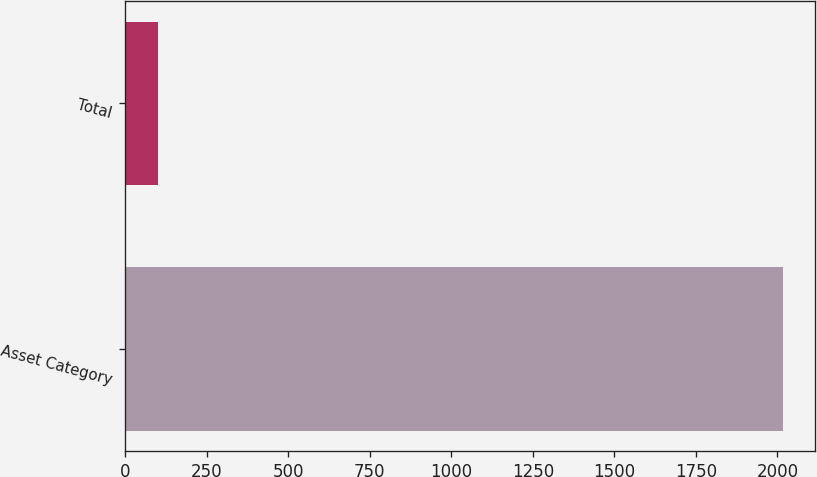<chart> <loc_0><loc_0><loc_500><loc_500><bar_chart><fcel>Asset Category<fcel>Total<nl><fcel>2016<fcel>100<nl></chart> 